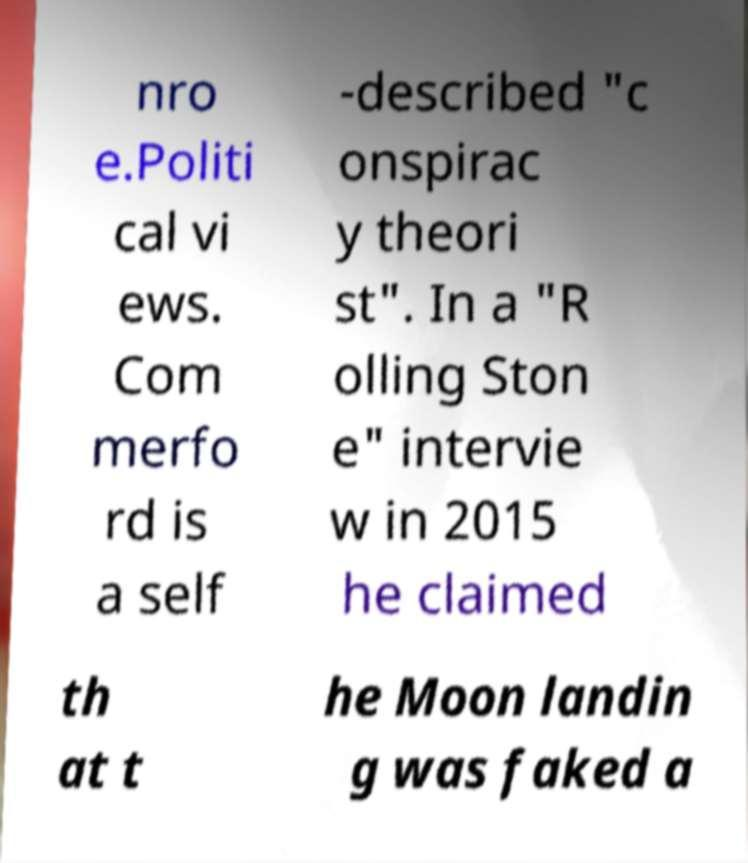For documentation purposes, I need the text within this image transcribed. Could you provide that? nro e.Politi cal vi ews. Com merfo rd is a self -described "c onspirac y theori st". In a "R olling Ston e" intervie w in 2015 he claimed th at t he Moon landin g was faked a 